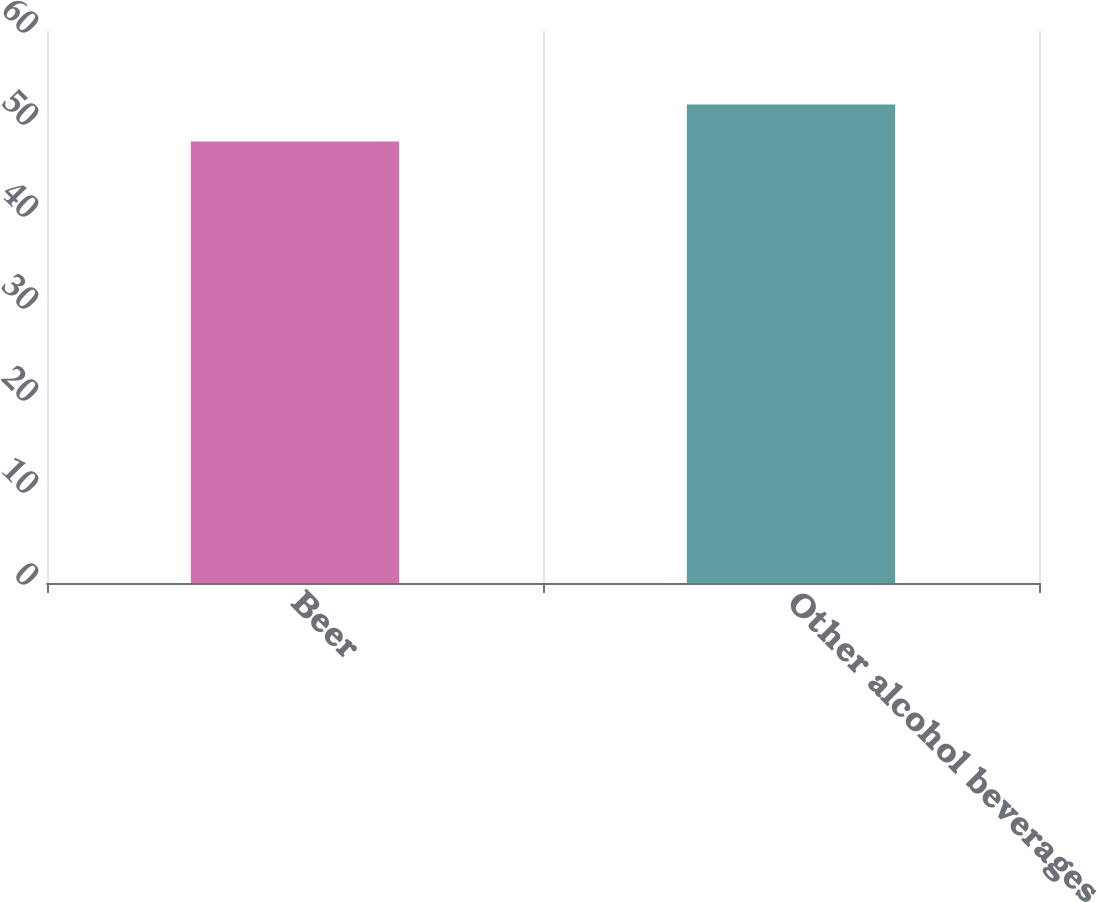Convert chart. <chart><loc_0><loc_0><loc_500><loc_500><bar_chart><fcel>Beer<fcel>Other alcohol beverages<nl><fcel>48<fcel>52<nl></chart> 